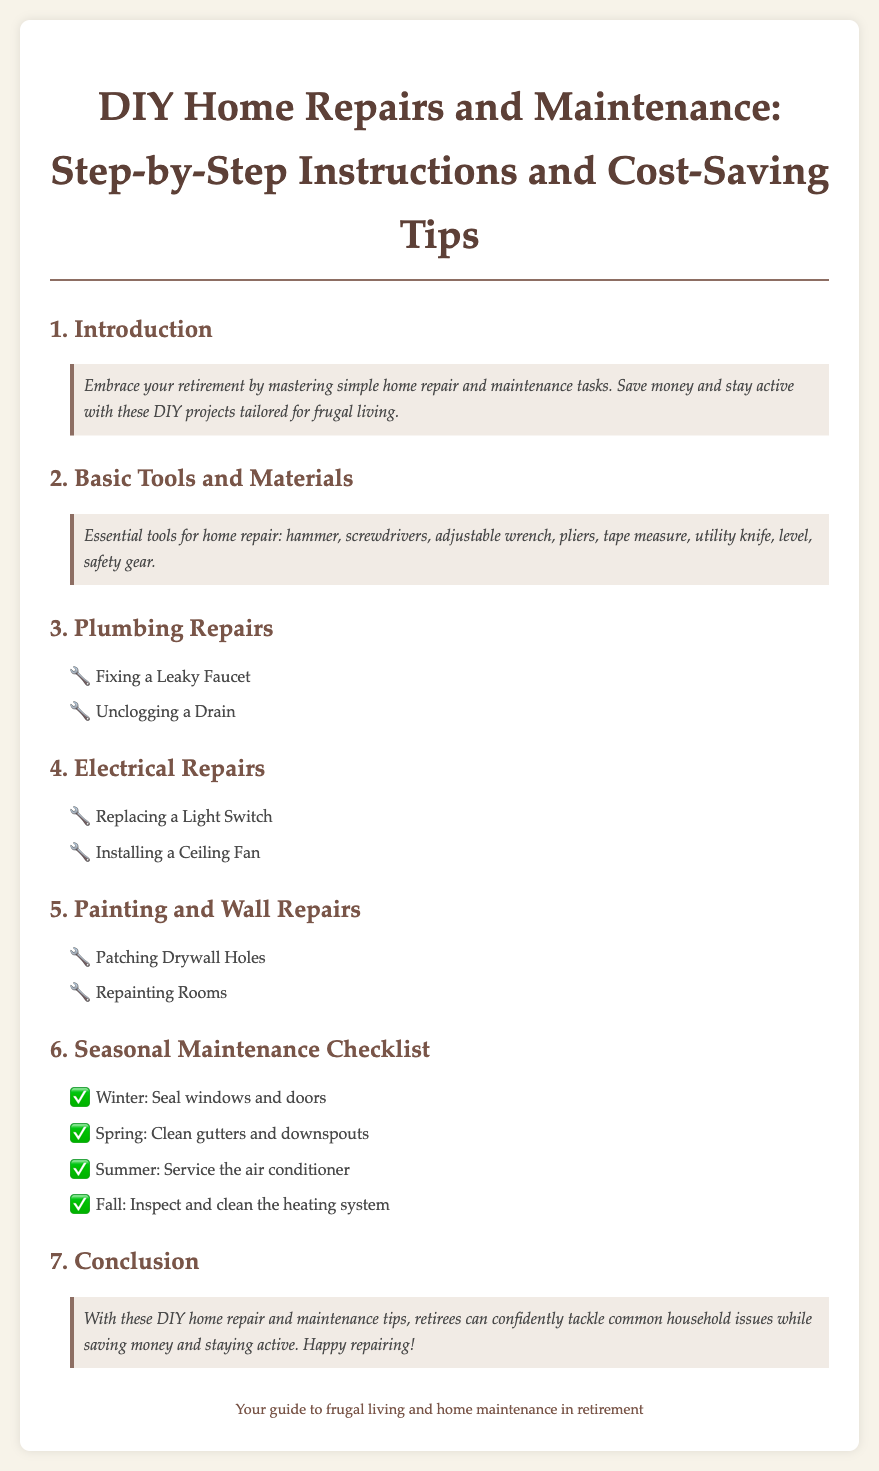what is the title of the document? The title of the document is provided at the beginning and is "DIY Home Repairs and Maintenance: Step-by-Step Instructions and Cost-Saving Tips."
Answer: DIY Home Repairs and Maintenance: Step-by-Step Instructions and Cost-Saving Tips how many sections are there in the index? The sections in the index include Introduction, Basic Tools and Materials, Plumbing Repairs, Electrical Repairs, Painting and Wall Repairs, Seasonal Maintenance Checklist, and Conclusion, which totals to seven sections.
Answer: 7 what type of task is suggested in the plumbing repairs section? The plumbing repairs section suggests tasks like fixing and unclogging, which are common plumbing issues.
Answer: fixing a leaky faucet, unclogging a drain which season involves cleaning gutters and downspouts? The Seasonal Maintenance Checklist specifies that cleaning gutters and downspouts is a task for the Spring.
Answer: Spring what is the purpose of the document? The purpose of the document is to provide guidance for retirees on home repair and maintenance while emphasizing the benefits of saving money and staying active.
Answer: guidance for retirees on home repair and maintenance which essential tools are mentioned in the basic tools and materials section? The basic tools and materials section lists essential tools like hammer, screwdrivers, and adjustable wrench.
Answer: hammer, screwdrivers, adjustable wrench what maintenance task is recommended for winter? The Seasonal Maintenance Checklist recommends sealing windows and doors during winter for maintenance.
Answer: Seal windows and doors what is the final message conveyed in the conclusion? The conclusion emphasizes that retirees can tackle household issues confidently while saving money and staying active.
Answer: tackle household issues confidently 